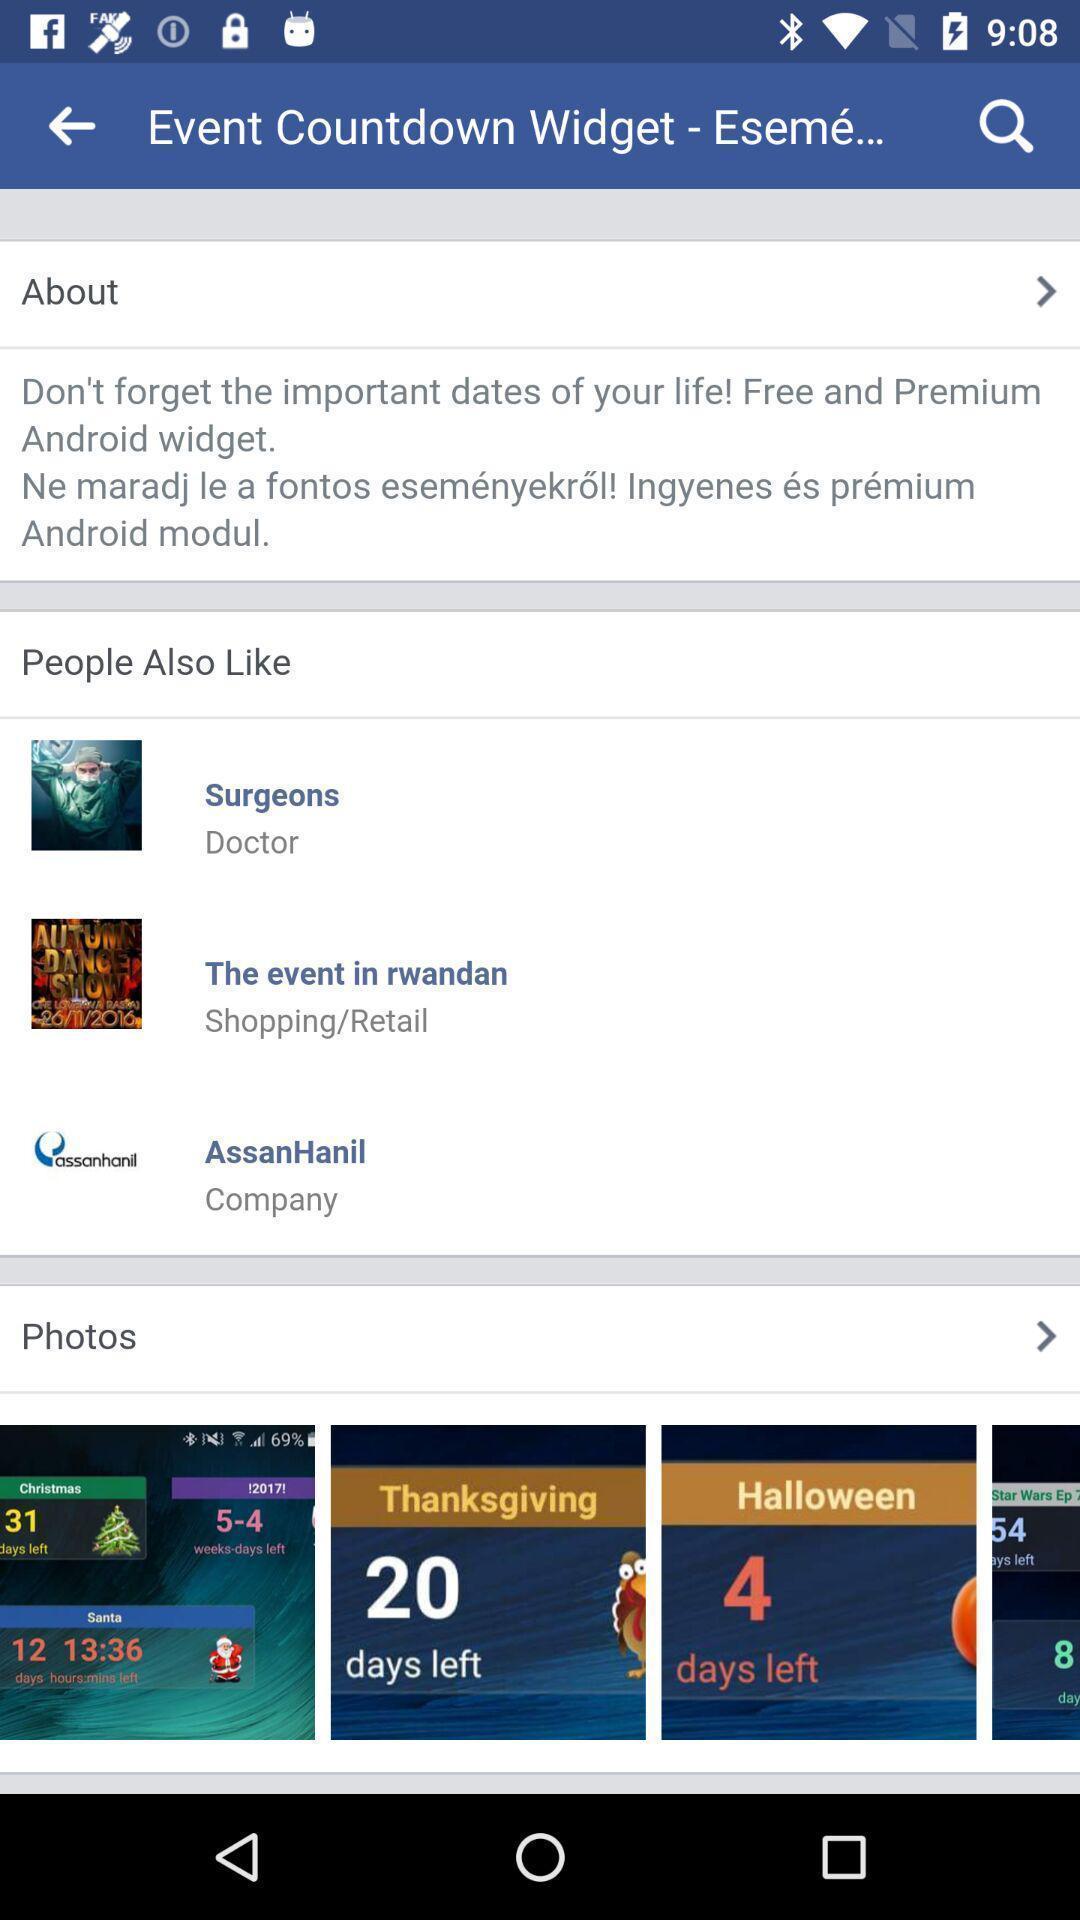Describe the visual elements of this screenshot. Search page of a countdown widget app. 